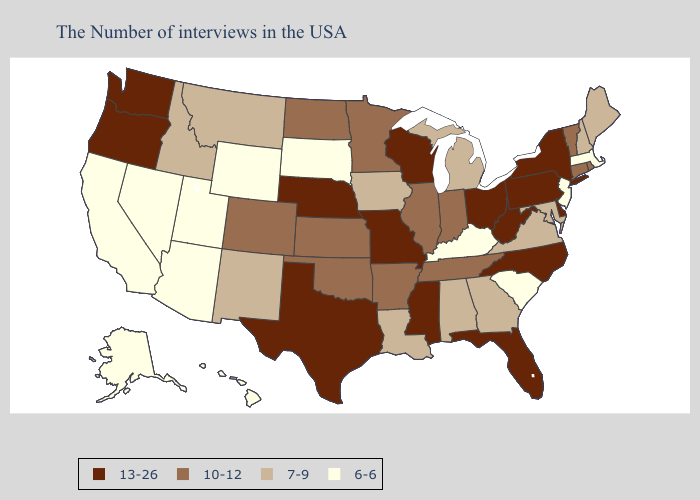Among the states that border Missouri , does Nebraska have the highest value?
Answer briefly. Yes. Among the states that border Arkansas , does Tennessee have the highest value?
Give a very brief answer. No. Name the states that have a value in the range 10-12?
Write a very short answer. Rhode Island, Vermont, Connecticut, Indiana, Tennessee, Illinois, Arkansas, Minnesota, Kansas, Oklahoma, North Dakota, Colorado. Which states have the lowest value in the MidWest?
Short answer required. South Dakota. Does the first symbol in the legend represent the smallest category?
Short answer required. No. Among the states that border Iowa , which have the highest value?
Answer briefly. Wisconsin, Missouri, Nebraska. Name the states that have a value in the range 13-26?
Concise answer only. New York, Delaware, Pennsylvania, North Carolina, West Virginia, Ohio, Florida, Wisconsin, Mississippi, Missouri, Nebraska, Texas, Washington, Oregon. Name the states that have a value in the range 6-6?
Answer briefly. Massachusetts, New Jersey, South Carolina, Kentucky, South Dakota, Wyoming, Utah, Arizona, Nevada, California, Alaska, Hawaii. What is the lowest value in the West?
Be succinct. 6-6. What is the value of Idaho?
Write a very short answer. 7-9. Does Mississippi have the same value as Delaware?
Quick response, please. Yes. Which states have the highest value in the USA?
Answer briefly. New York, Delaware, Pennsylvania, North Carolina, West Virginia, Ohio, Florida, Wisconsin, Mississippi, Missouri, Nebraska, Texas, Washington, Oregon. Among the states that border Michigan , does Ohio have the lowest value?
Short answer required. No. Which states have the lowest value in the West?
Short answer required. Wyoming, Utah, Arizona, Nevada, California, Alaska, Hawaii. What is the value of Massachusetts?
Give a very brief answer. 6-6. 